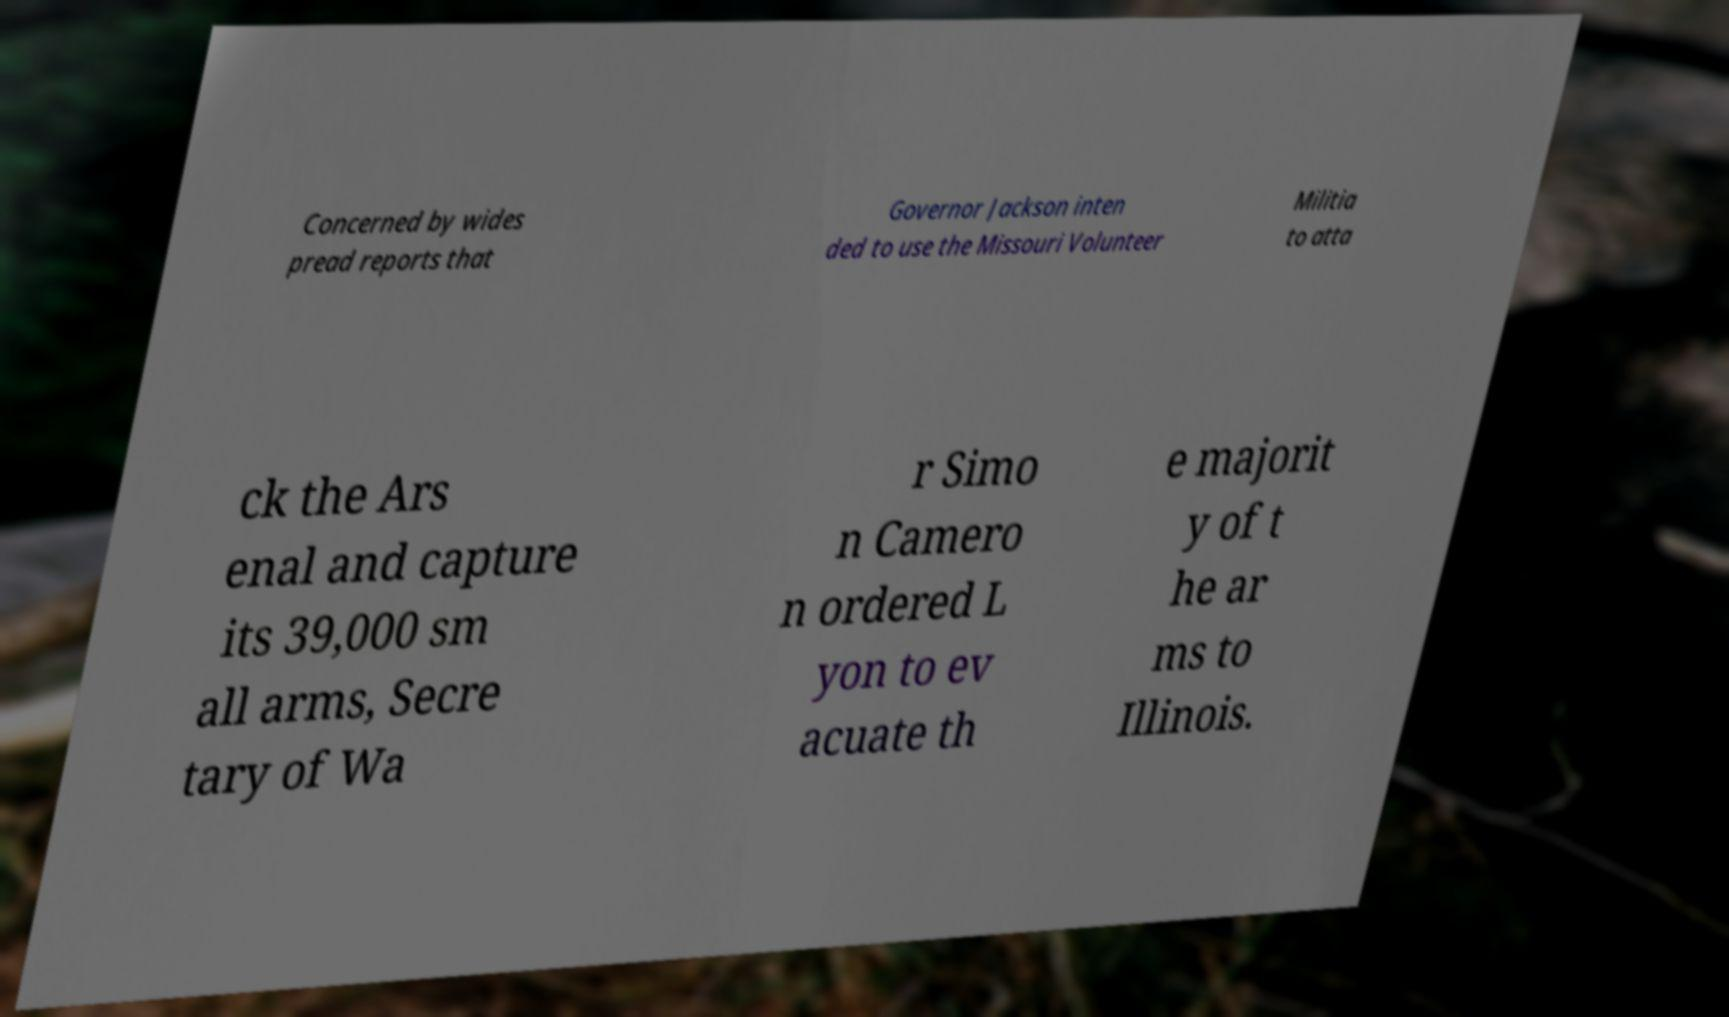Can you read and provide the text displayed in the image?This photo seems to have some interesting text. Can you extract and type it out for me? Concerned by wides pread reports that Governor Jackson inten ded to use the Missouri Volunteer Militia to atta ck the Ars enal and capture its 39,000 sm all arms, Secre tary of Wa r Simo n Camero n ordered L yon to ev acuate th e majorit y of t he ar ms to Illinois. 